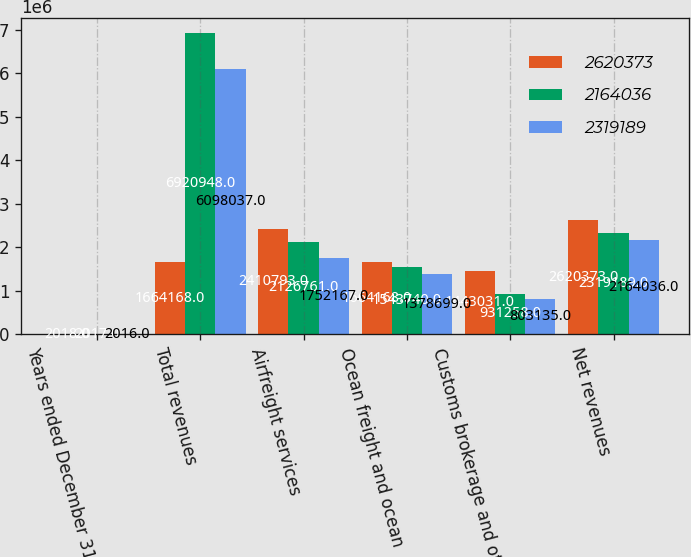Convert chart to OTSL. <chart><loc_0><loc_0><loc_500><loc_500><stacked_bar_chart><ecel><fcel>Years ended December 31<fcel>Total revenues<fcel>Airfreight services<fcel>Ocean freight and ocean<fcel>Customs brokerage and other<fcel>Net revenues<nl><fcel>2.62037e+06<fcel>2018<fcel>1.66417e+06<fcel>2.41079e+06<fcel>1.66417e+06<fcel>1.44303e+06<fcel>2.62037e+06<nl><fcel>2.16404e+06<fcel>2017<fcel>6.92095e+06<fcel>2.12676e+06<fcel>1.54374e+06<fcel>931258<fcel>2.31919e+06<nl><fcel>2.31919e+06<fcel>2016<fcel>6.09804e+06<fcel>1.75217e+06<fcel>1.3787e+06<fcel>803135<fcel>2.16404e+06<nl></chart> 